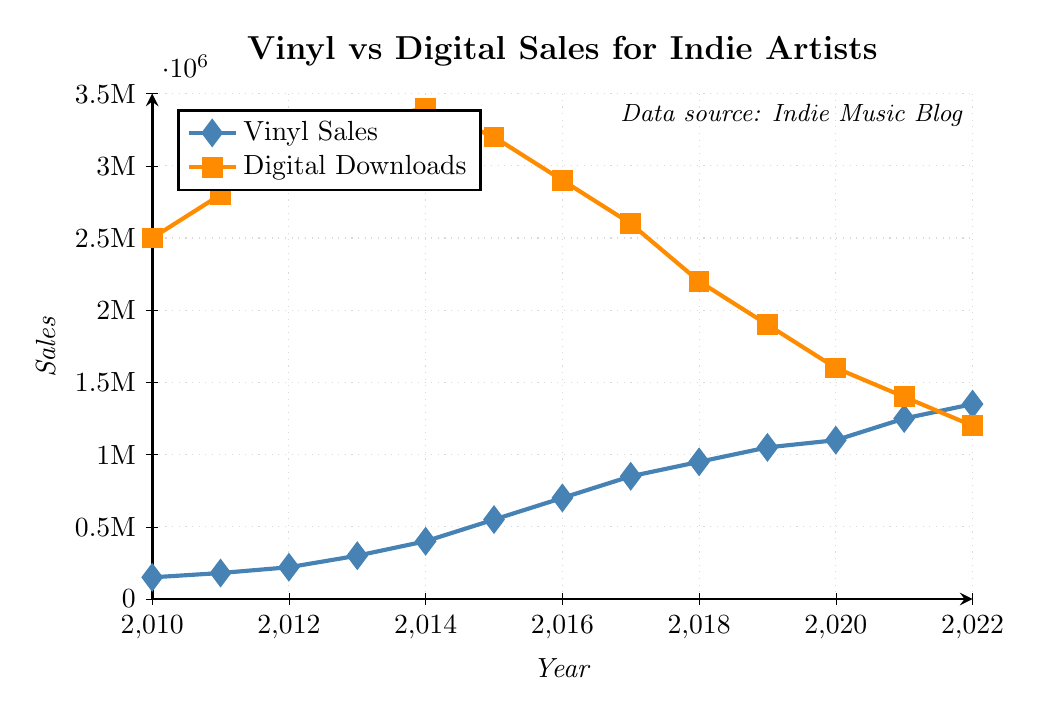what trend can be observed in vinyl sales for indie artists between 2010 and 2022? Vinyl sales for indie artists have shown a steady and significant increase from 2010 to 2022. In 2010, vinyl sales were at 150,000 and rose to 1,350,000 by 2022.
Answer: Steady increase How did digital download sales for indie artists change from 2014 to 2020? Digital download sales for indie artists decreased from 3,400,000 in 2014 to 1,600,000 in 2020. This shows a decline over this period.
Answer: Decreased In which year did vinyl sales surpass digital download sales for indie artists? Vinyl sales surpassed digital download sales for indie artists in 2021. Vinyl sales reached 1,250,000 while digital downloads were at 1,400,000 in 2020, but the next year, vinyl sales surpassed digital downloads.
Answer: 2021 What is the overall trend observed in digital download sales for indie artists between 2010 and 2022? Digital download sales for indie artists initially increased from 2010 to 2014 and then started to decline from 2015 onwards. In 2010, sales were 2,500,000 and peaked at 3,400,000 in 2014, but by 2022, they decreased to 1,200,000.
Answer: Increase then decrease What is the difference in vinyl sales between 2013 and 2018? In 2013, vinyl sales were 300,000, and in 2018, they were 950,000. The difference is 950,000 - 300,000 = 650,000.
Answer: 650,000 Which year showed the highest digital download sales for indie artists and what was the value? The year 2014 showed the highest digital download sales for indie artists with a value of 3,400,000.
Answer: 2014, 3,400,000 Compare the vinyl and digital download sales trends from 2015 to 2022. What key differences can you identify? From 2015 to 2022, vinyl sales showed a consistent upward trend, increasing from 550,000 to 1,350,000. In contrast, digital download sales showed a consistent downward trend, decreasing from 3,200,000 to 1,200,000.
Answer: Vinyl increased, Digital decreased How much did vinyl sales increase in absolute numbers from 2010 to 2022? Vinyl sales in 2010 were 150,000 and increased to 1,350,000 in 2022. The increase in absolute numbers is 1,350,000 - 150,000 = 1,200,000.
Answer: 1,200,000 What color represents digital download sales in the chart and why is it important in interpreting the data? Digital download sales are represented by the color orange in the chart. This is important for quickly distinguishing digital download trends from vinyl sales which are represented in blue.
Answer: Orange 